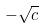Convert formula to latex. <formula><loc_0><loc_0><loc_500><loc_500>- \sqrt { c }</formula> 